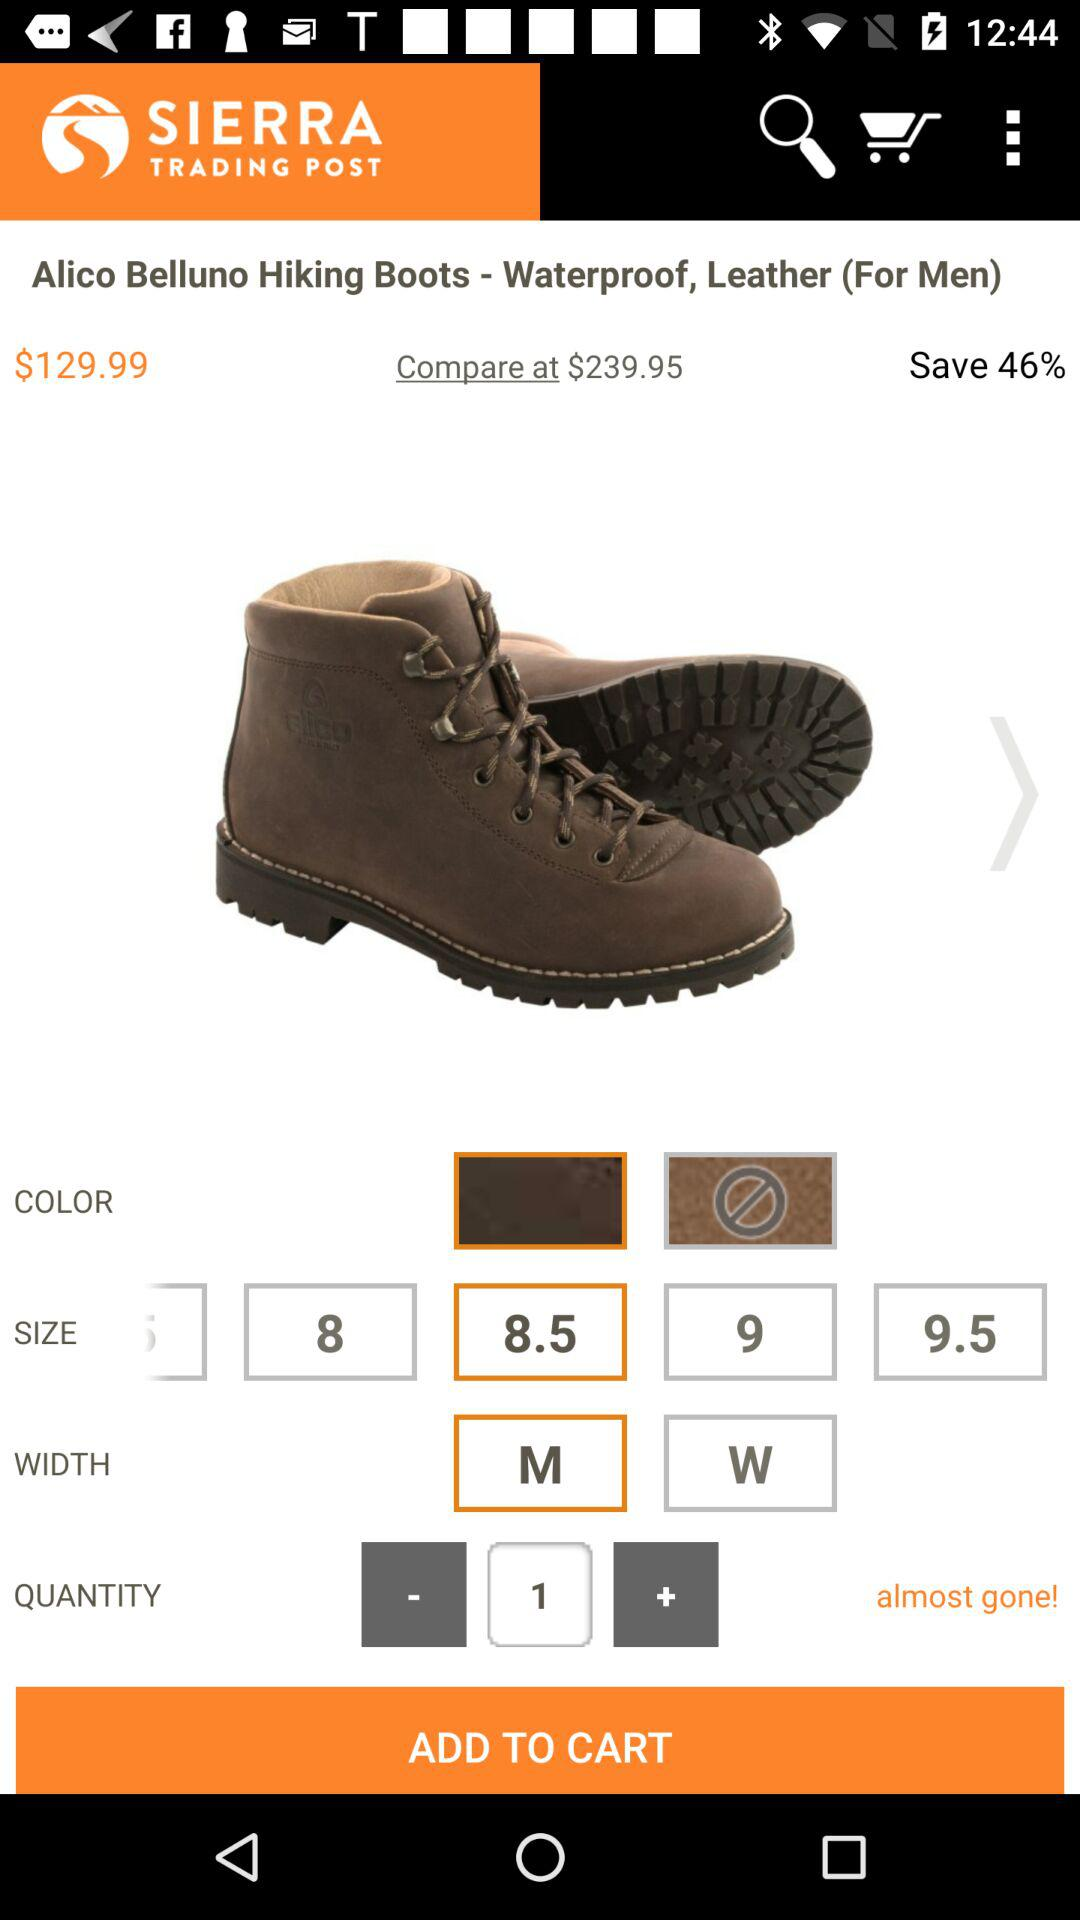What is the quantity? The quantity is 1. 